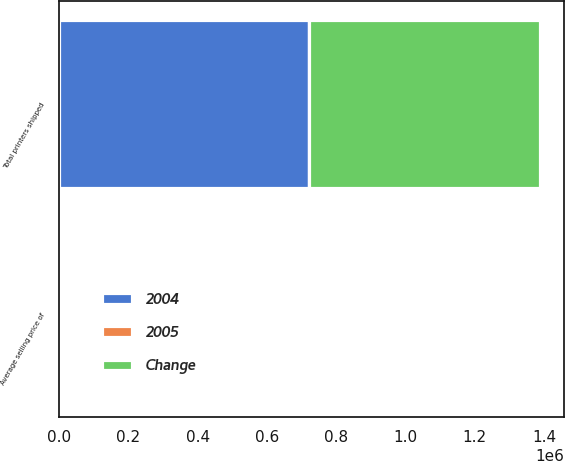<chart> <loc_0><loc_0><loc_500><loc_500><stacked_bar_chart><ecel><fcel>Total printers shipped<fcel>Average selling price of<nl><fcel>2004<fcel>720306<fcel>633<nl><fcel>Change<fcel>667461<fcel>652<nl><fcel>2005<fcel>7.9<fcel>2.9<nl></chart> 